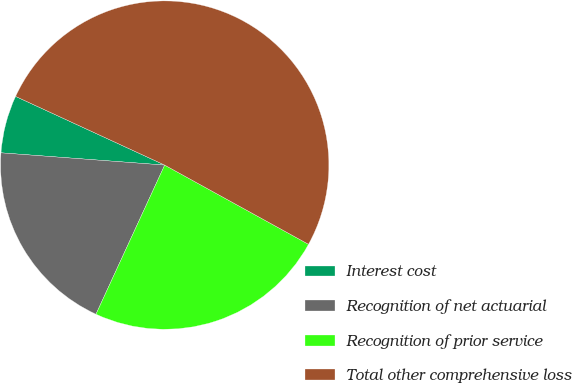Convert chart. <chart><loc_0><loc_0><loc_500><loc_500><pie_chart><fcel>Interest cost<fcel>Recognition of net actuarial<fcel>Recognition of prior service<fcel>Total other comprehensive loss<nl><fcel>5.68%<fcel>19.32%<fcel>23.86%<fcel>51.14%<nl></chart> 